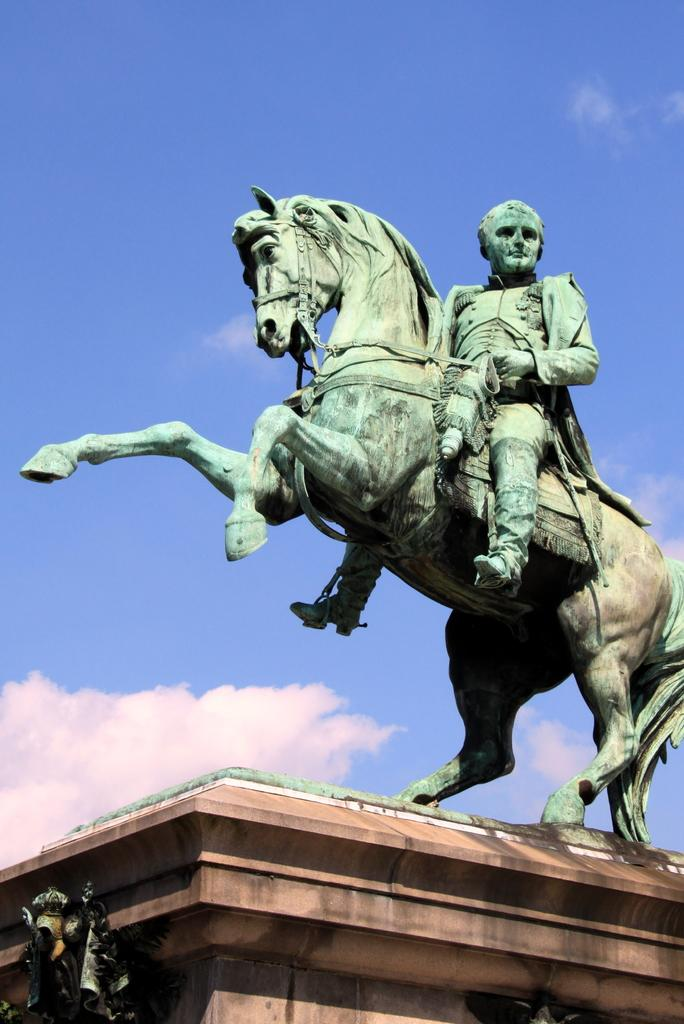What is the main subject of the image? There is a statue of a horse in the image. Is there anyone interacting with the statue? Yes, a person is sitting on the horse statue. What is the statue placed on? The statue is on a brown-colored object. What can be seen in the background of the image? The sky is visible in the background of the image. What type of ducks can be seen swimming in the person's stomach in the image? There are no ducks present in the image, and the person's stomach is not visible. 